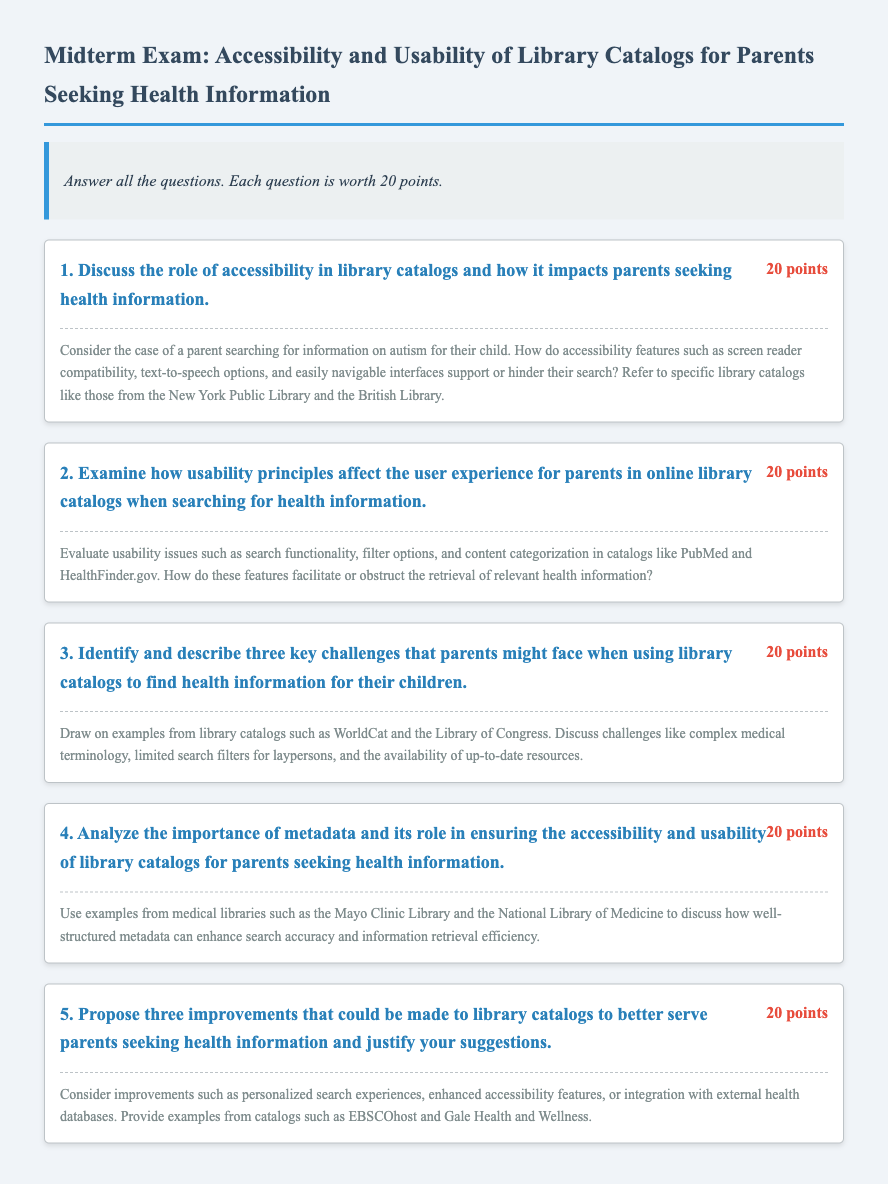What is the title of the midterm exam? The title, as stated in the document, is "Midterm Exam: Accessibility and Usability of Library Catalogs for Parents Seeking Health Information."
Answer: Midterm Exam: Accessibility and Usability of Library Catalogs for Parents Seeking Health Information How many points are each question worth? The document states that each question is worth 20 points.
Answer: 20 points Name one library catalog referenced in the first question. The first question mentions the New York Public Library as a specific example.
Answer: New York Public Library What is one usability issue mentioned in question two? Question two highlights usability issues such as search functionality, filter options, and content categorization.
Answer: Search functionality How many key challenges does question three ask to identify? Question three asks for the identification of three key challenges faced by parents.
Answer: Three Which library is used as an example to discuss metadata in question four? Question four uses the Mayo Clinic Library as an example when discussing metadata.
Answer: Mayo Clinic Library What improvement is suggested in question five? One of the suggested improvements in question five is enhanced accessibility features.
Answer: Enhanced accessibility features What type of prompt is included under each question? Each question features an extended prompt that elaborates on the main question.
Answer: Extended prompt Name the style used for the body font in the document. The body font style used in the document is 'Merriweather'.
Answer: Merriweather 